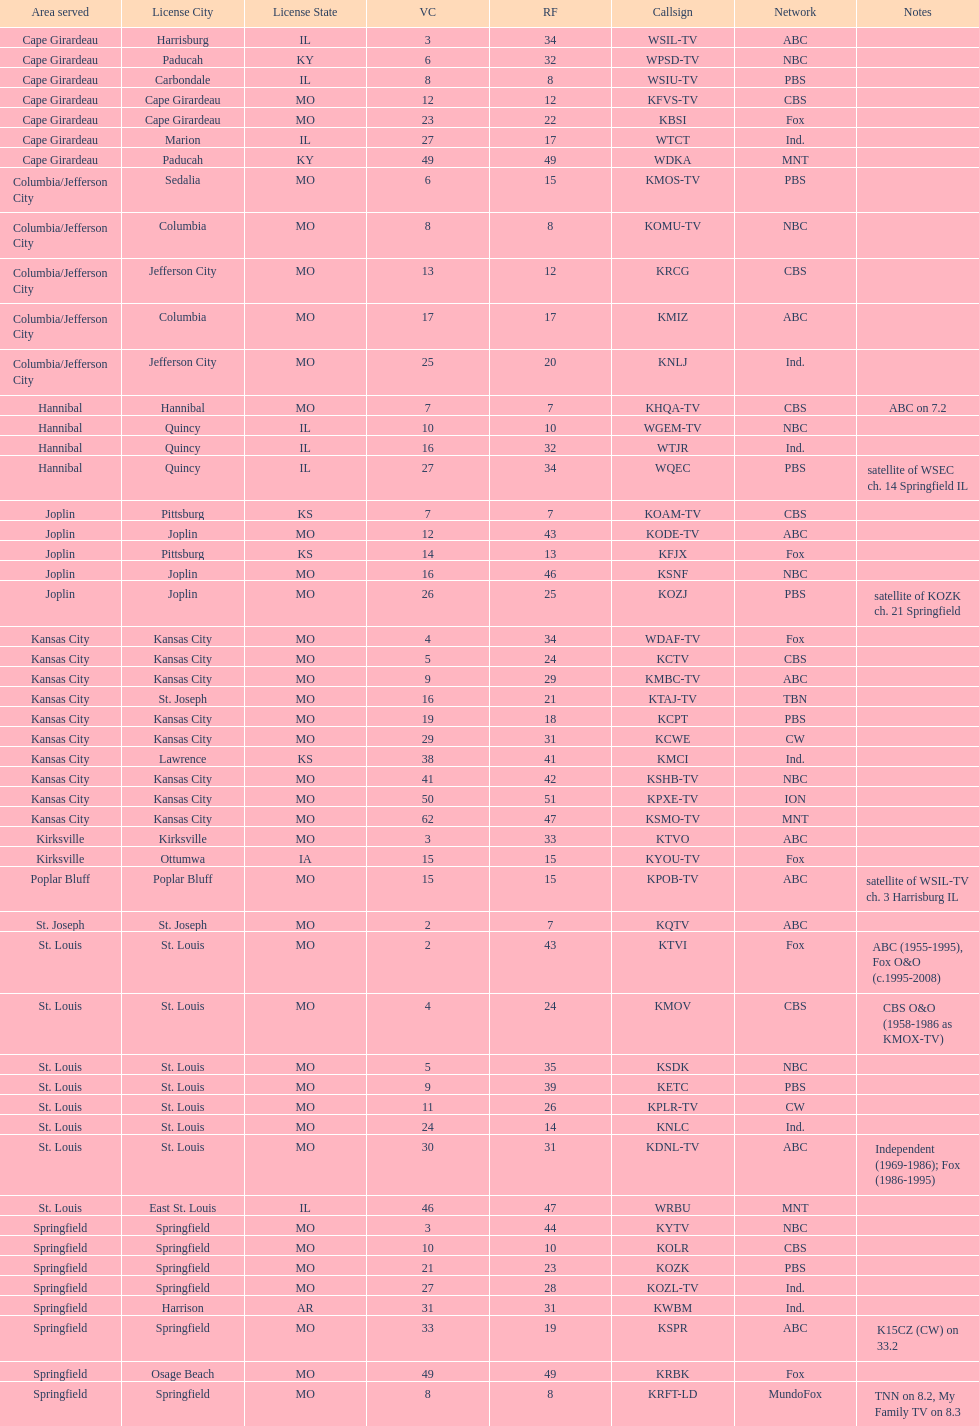How many television stations serve the cape girardeau area? 7. 